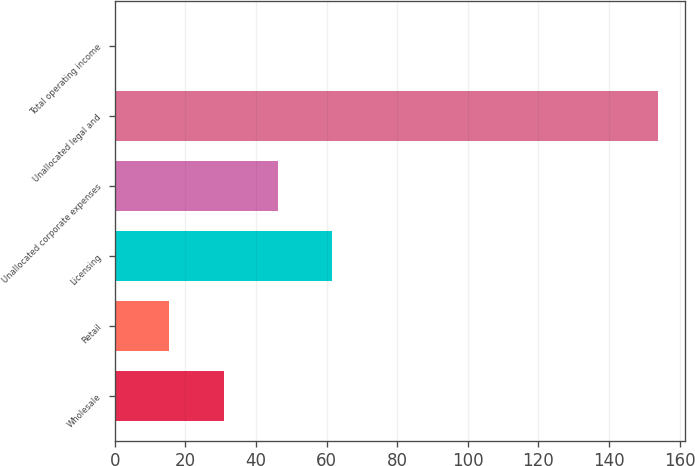Convert chart to OTSL. <chart><loc_0><loc_0><loc_500><loc_500><bar_chart><fcel>Wholesale<fcel>Retail<fcel>Licensing<fcel>Unallocated corporate expenses<fcel>Unallocated legal and<fcel>Total operating income<nl><fcel>30.86<fcel>15.48<fcel>61.62<fcel>46.24<fcel>153.9<fcel>0.1<nl></chart> 